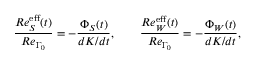Convert formula to latex. <formula><loc_0><loc_0><loc_500><loc_500>\frac { R e _ { S } ^ { e f f } ( t ) } { R e _ { \Gamma _ { 0 } } } = - \frac { \Phi _ { S } ( t ) } { d K / d t } , \quad \frac { R e _ { W } ^ { e f f } ( t ) } { R e _ { \Gamma _ { 0 } } } = - \frac { \Phi _ { W } ( t ) } { d K / d t } ,</formula> 